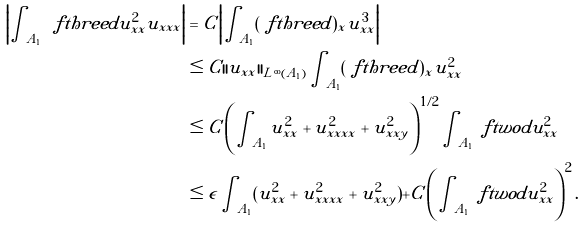Convert formula to latex. <formula><loc_0><loc_0><loc_500><loc_500>\left | \int _ { A _ { 1 } } \ f t h r e e d u _ { x x } ^ { 2 } u _ { x x x } \right | & = C \left | \int _ { A _ { 1 } } ( \ f t h r e e d ) _ { x } u _ { x x } ^ { 3 } \right | \\ & \leq C | | u _ { x x } | | _ { L ^ { \infty } ( A _ { 1 } ) } \int _ { A _ { 1 } } ( \ f t h r e e d ) _ { x } u _ { x x } ^ { 2 } \\ & \leq C \left ( \int _ { A _ { 1 } } u _ { x x } ^ { 2 } + u _ { x x x x } ^ { 2 } + u _ { x x y } ^ { 2 } \right ) ^ { 1 / 2 } \int _ { A _ { 1 } } \ f t w o d u _ { x x } ^ { 2 } \\ & \leq \epsilon \int _ { A _ { 1 } } ( u _ { x x } ^ { 2 } + u _ { x x x x } ^ { 2 } + u _ { x x y } ^ { 2 } ) + C \left ( \int _ { A _ { 1 } } \ f t w o d u _ { x x } ^ { 2 } \right ) ^ { 2 } .</formula> 